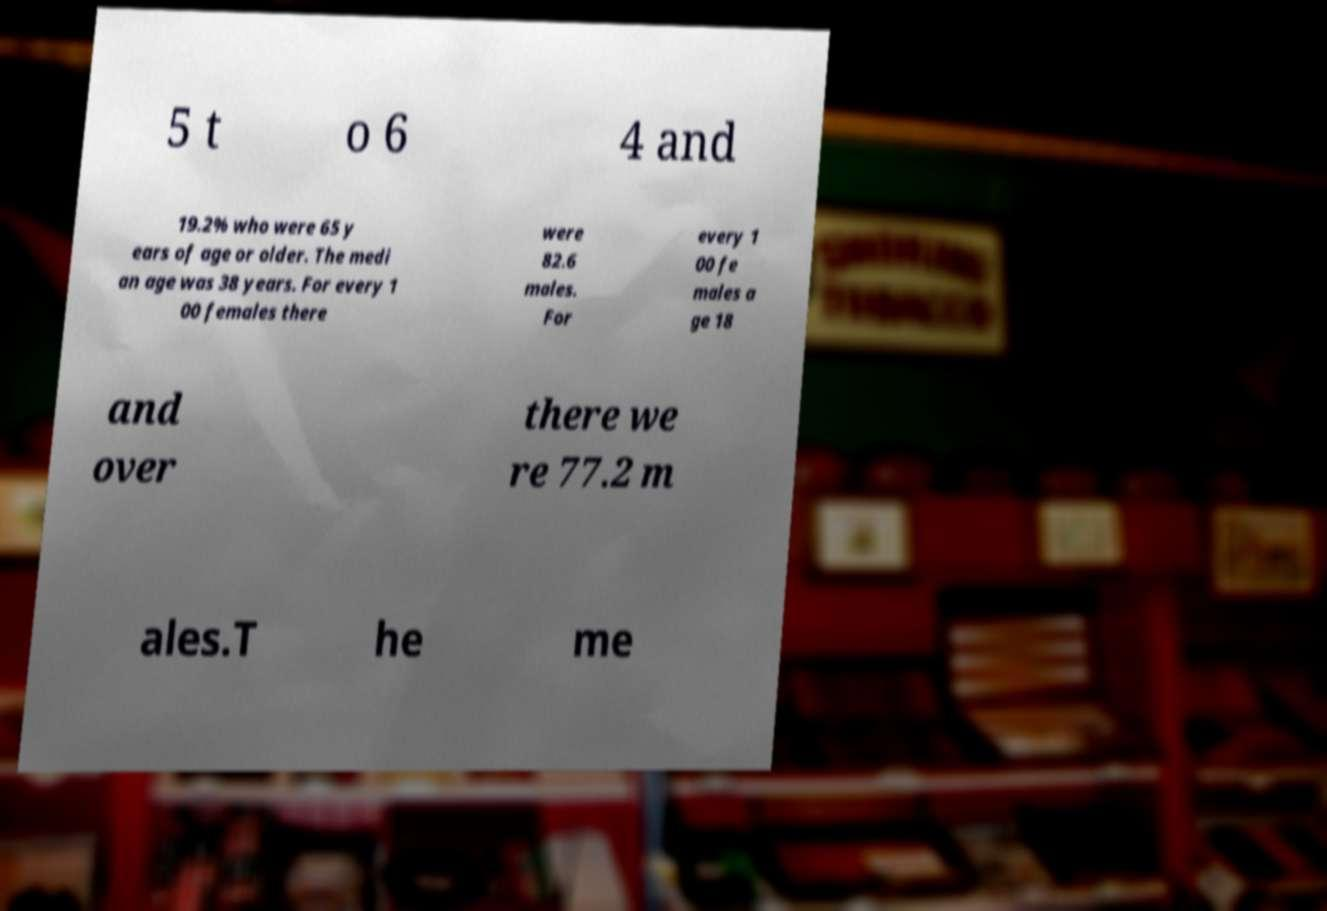Could you assist in decoding the text presented in this image and type it out clearly? 5 t o 6 4 and 19.2% who were 65 y ears of age or older. The medi an age was 38 years. For every 1 00 females there were 82.6 males. For every 1 00 fe males a ge 18 and over there we re 77.2 m ales.T he me 